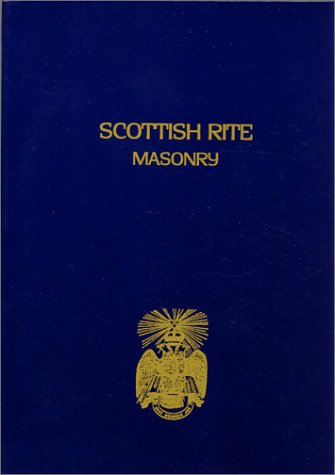What symbols can be seen on the cover of the book? The cover features a distinctive double-headed eagle, a well-known symbol associated with the Scottish Rite, representing the merging of various historical influences in Masonic rituals and teachings. 